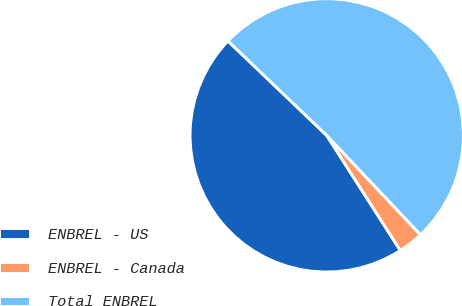<chart> <loc_0><loc_0><loc_500><loc_500><pie_chart><fcel>ENBREL - US<fcel>ENBREL - Canada<fcel>Total ENBREL<nl><fcel>46.2%<fcel>2.98%<fcel>50.82%<nl></chart> 